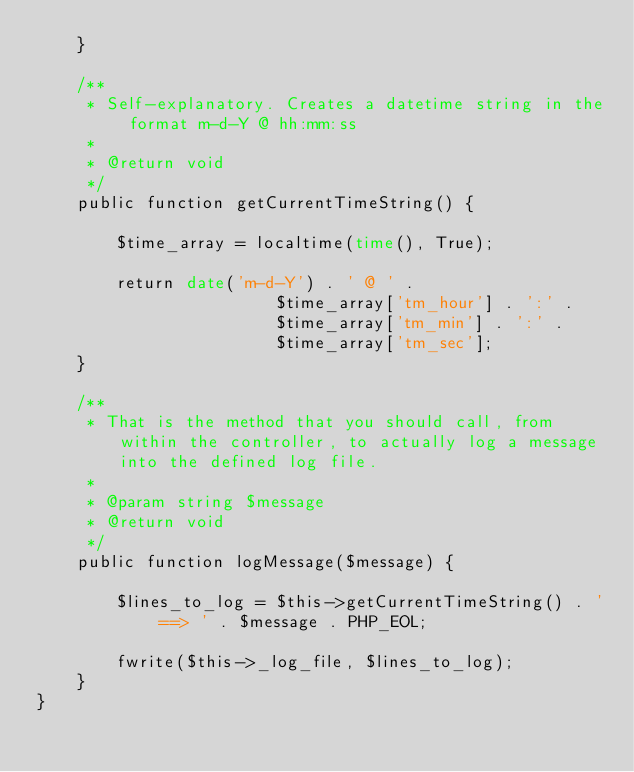<code> <loc_0><loc_0><loc_500><loc_500><_PHP_>    }

    /**
     * Self-explanatory. Creates a datetime string in the format m-d-Y @ hh:mm:ss
     *
     * @return void
     */
    public function getCurrentTimeString() {
    
        $time_array = localtime(time(), True);
        
        return date('m-d-Y') . ' @ ' . 
                        $time_array['tm_hour'] . ':' .
                        $time_array['tm_min'] . ':' .
                        $time_array['tm_sec'];
    }

    /**
     * That is the method that you should call, from within the controller, to actually log a message into the defined log file.
     *
     * @param string $message
     * @return void
     */
    public function logMessage($message) {

        $lines_to_log = $this->getCurrentTimeString() . ' ==> ' . $message . PHP_EOL;

        fwrite($this->_log_file, $lines_to_log);
    }
}</code> 